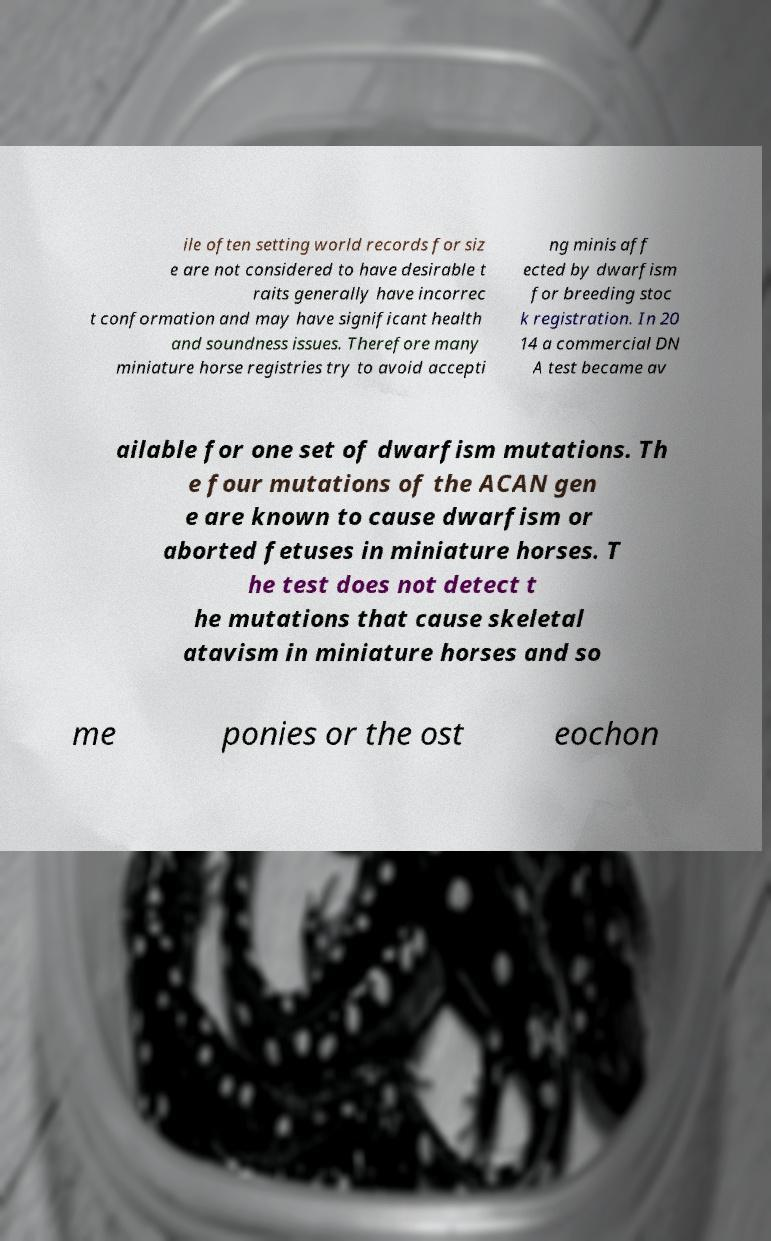Can you read and provide the text displayed in the image?This photo seems to have some interesting text. Can you extract and type it out for me? ile often setting world records for siz e are not considered to have desirable t raits generally have incorrec t conformation and may have significant health and soundness issues. Therefore many miniature horse registries try to avoid accepti ng minis aff ected by dwarfism for breeding stoc k registration. In 20 14 a commercial DN A test became av ailable for one set of dwarfism mutations. Th e four mutations of the ACAN gen e are known to cause dwarfism or aborted fetuses in miniature horses. T he test does not detect t he mutations that cause skeletal atavism in miniature horses and so me ponies or the ost eochon 